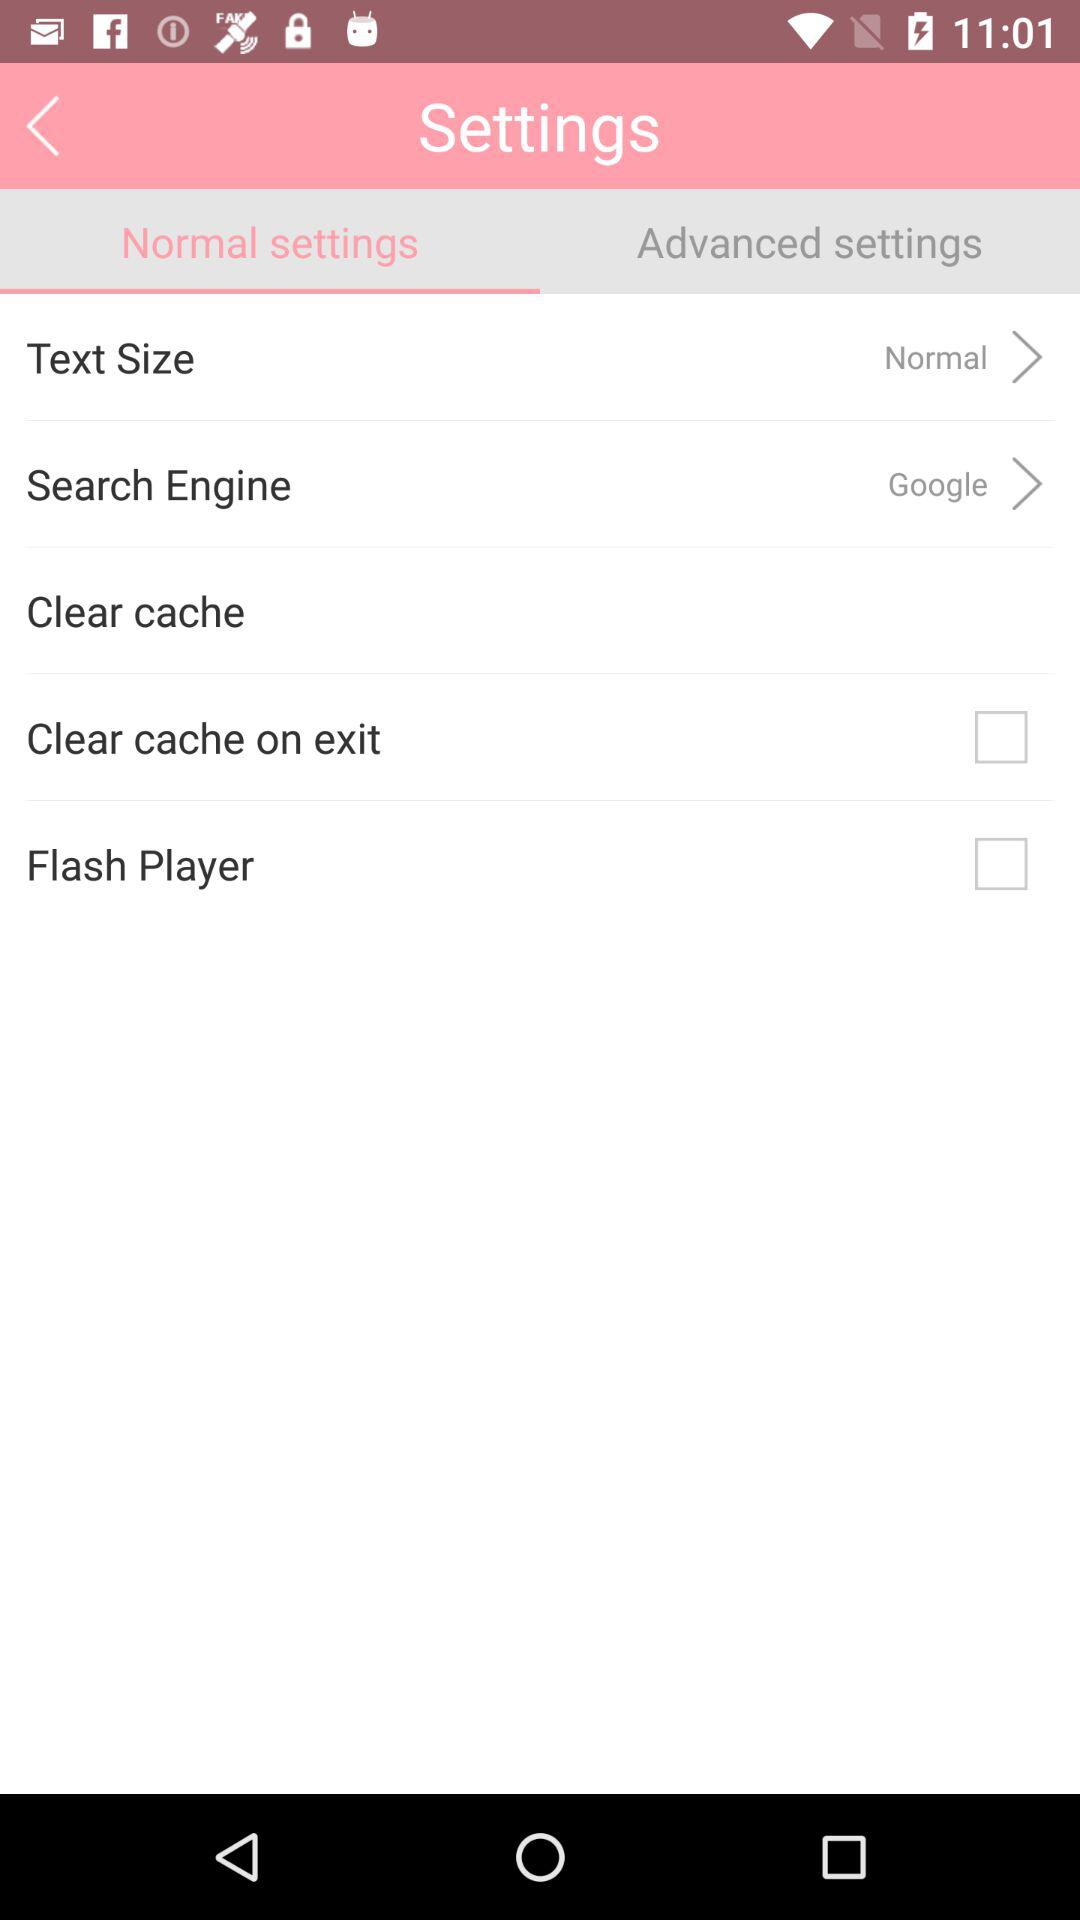How many checkboxes are present in the settings menu?
Answer the question using a single word or phrase. 2 